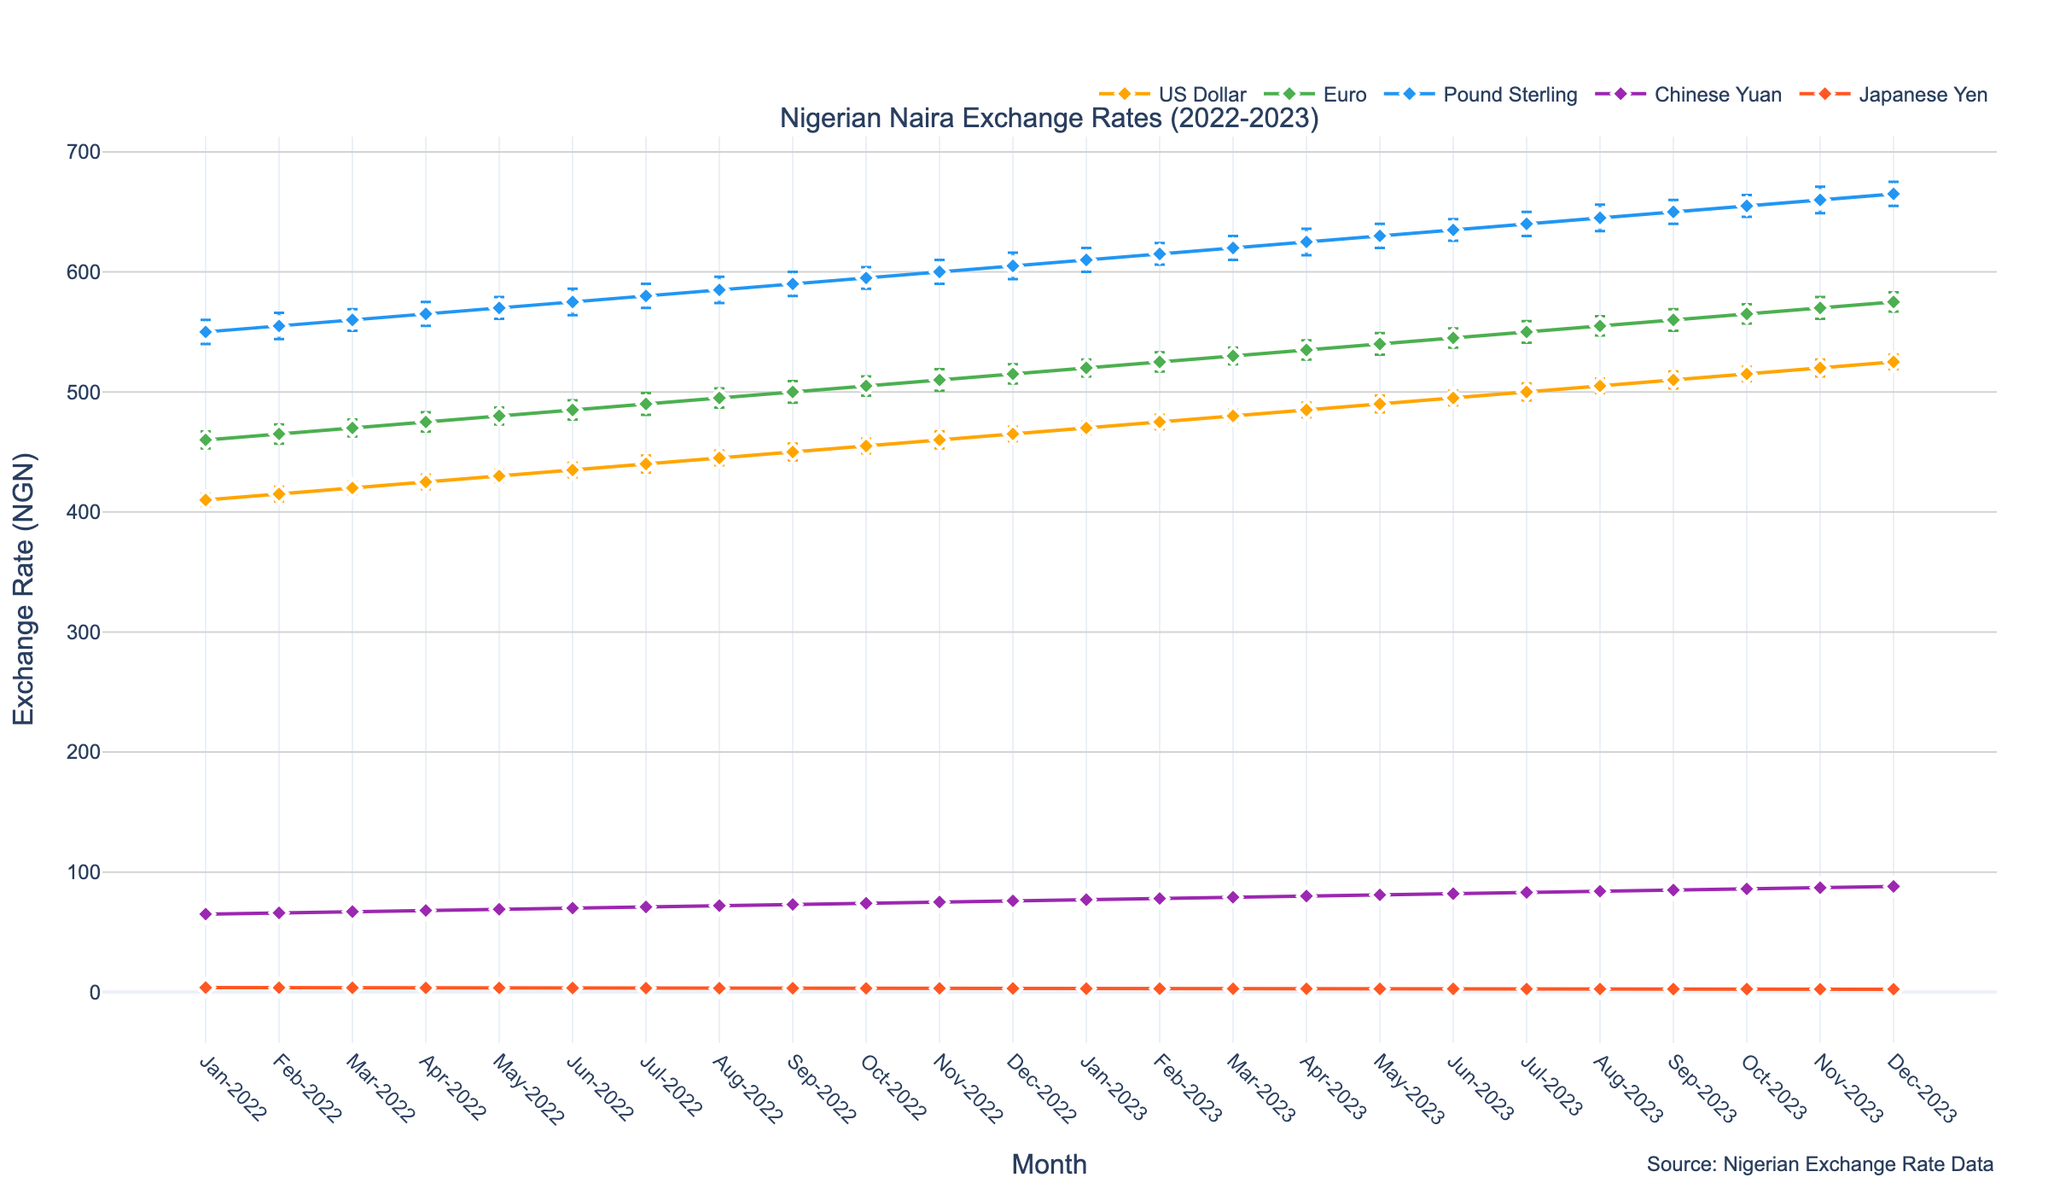what is the highest exchange rate for the US Dollar in 2022? The chart's x-axis represents months, and the y-axis represents exchange rates. The highest exchange rate for the US Dollar in 2022 occurs in December with a rate of 465 NGN.
Answer: 465 NGN Which currency had the smallest confidence interval in March 2022? Confidence intervals are represented as vertical error bars on the chart. In March 2022, the Japanese Yen has the smallest interval with an error margin of 0.2.
Answer: Japanese Yen Compare the exchange rates of the Euro and Pound Sterling in January 2023. Which one is higher? Referring to the plot, in January 2023, the exchange rate for the Euro is 520 NGN, and for the Pound Sterling, it is 610 NGN. The Pound Sterling has a higher exchange rate than the Euro.
Answer: Pound Sterling What is the average exchange rate for the US Dollar from January 2022 to December 2022? To find the average, sum up the monthly exchange rates for the US Dollar from January to December 2022 and divide by 12. (410 + 415 + 420 + 425 + 430 + 435 + 440 + 445 + 450 + 455 + 460 + 465) / 12 = 436.25
Answer: 436.25 NGN How did the exchange rate of the Chinese Yuan change from June 2022 to January 2023? In June 2022, the exchange rate for the Chinese Yuan was 70 NGN. By January 2023, it increased to 77 NGN. The rate increased by 7 NGN.
Answer: Increased by 7 NGN Which currency shows the most consistent exchange rate change throughout the period? A consistent change would be reflected by a smooth line with smaller error bars. The US Dollar shows the most consistent exchange rate change with uniform steps and relatively small confidence intervals.
Answer: US Dollar In July 2023, what was the difference between the exchange rate of the Euro and the Japanese Yen? By looking at the rates in July 2023, the Euro was at 550 NGN and the Japanese Yen at 2.6 NGN. The difference is 550 - 2.6 = 547.4 NGN.
Answer: 547.4 NGN Did the exchange rate for any currency decrease over any month? The plot shows all currencies except the Japanese Yen have a steady or increasing trend. The Japanese Yen shows a slight decrease from 3.7 in February 2022 to 3.6 in March 2022, and another from 3.4 in June 2022 to 3.3 in July 2022.
Answer: Yes, Japanese Yen 